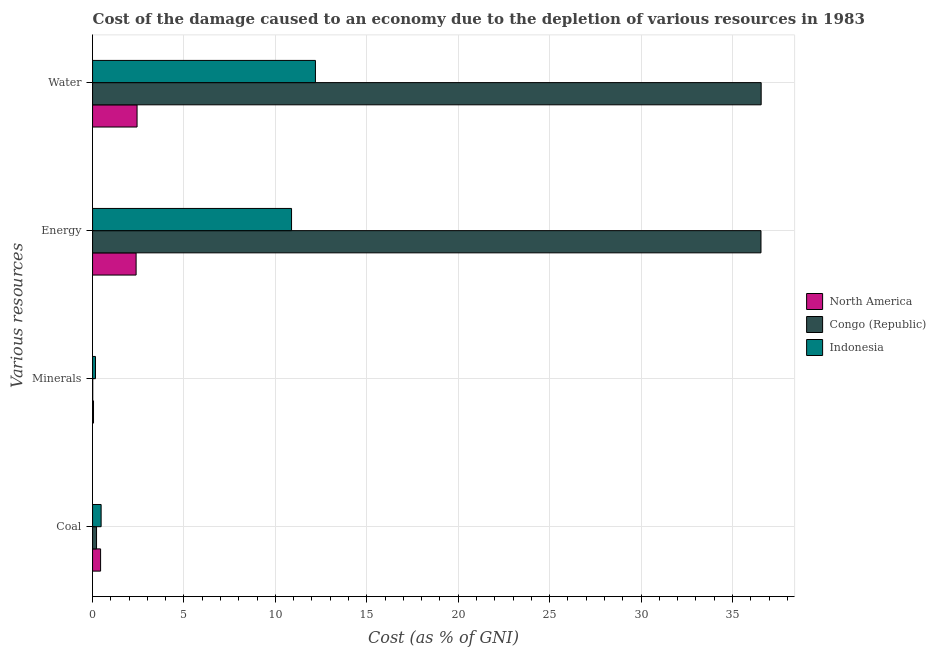Are the number of bars on each tick of the Y-axis equal?
Your response must be concise. Yes. How many bars are there on the 2nd tick from the top?
Give a very brief answer. 3. How many bars are there on the 1st tick from the bottom?
Provide a short and direct response. 3. What is the label of the 3rd group of bars from the top?
Provide a succinct answer. Minerals. What is the cost of damage due to depletion of water in Congo (Republic)?
Offer a terse response. 36.57. Across all countries, what is the maximum cost of damage due to depletion of energy?
Your response must be concise. 36.56. Across all countries, what is the minimum cost of damage due to depletion of energy?
Your answer should be compact. 2.38. In which country was the cost of damage due to depletion of energy maximum?
Offer a terse response. Congo (Republic). In which country was the cost of damage due to depletion of minerals minimum?
Keep it short and to the point. Congo (Republic). What is the total cost of damage due to depletion of minerals in the graph?
Offer a terse response. 0.22. What is the difference between the cost of damage due to depletion of minerals in North America and that in Indonesia?
Your answer should be compact. -0.11. What is the difference between the cost of damage due to depletion of water in Indonesia and the cost of damage due to depletion of minerals in North America?
Your response must be concise. 12.14. What is the average cost of damage due to depletion of coal per country?
Give a very brief answer. 0.37. What is the difference between the cost of damage due to depletion of minerals and cost of damage due to depletion of energy in Indonesia?
Provide a short and direct response. -10.72. What is the ratio of the cost of damage due to depletion of water in North America to that in Indonesia?
Provide a short and direct response. 0.2. Is the cost of damage due to depletion of energy in North America less than that in Congo (Republic)?
Your response must be concise. Yes. Is the difference between the cost of damage due to depletion of coal in North America and Indonesia greater than the difference between the cost of damage due to depletion of energy in North America and Indonesia?
Your answer should be compact. Yes. What is the difference between the highest and the second highest cost of damage due to depletion of water?
Provide a succinct answer. 24.38. What is the difference between the highest and the lowest cost of damage due to depletion of energy?
Offer a terse response. 34.17. Is the sum of the cost of damage due to depletion of minerals in Indonesia and Congo (Republic) greater than the maximum cost of damage due to depletion of coal across all countries?
Make the answer very short. No. What does the 2nd bar from the bottom in Water represents?
Keep it short and to the point. Congo (Republic). How many countries are there in the graph?
Make the answer very short. 3. Does the graph contain grids?
Ensure brevity in your answer.  Yes. Where does the legend appear in the graph?
Give a very brief answer. Center right. How are the legend labels stacked?
Give a very brief answer. Vertical. What is the title of the graph?
Your response must be concise. Cost of the damage caused to an economy due to the depletion of various resources in 1983 . Does "Fragile and conflict affected situations" appear as one of the legend labels in the graph?
Provide a succinct answer. No. What is the label or title of the X-axis?
Provide a short and direct response. Cost (as % of GNI). What is the label or title of the Y-axis?
Ensure brevity in your answer.  Various resources. What is the Cost (as % of GNI) in North America in Coal?
Keep it short and to the point. 0.44. What is the Cost (as % of GNI) of Congo (Republic) in Coal?
Make the answer very short. 0.22. What is the Cost (as % of GNI) of Indonesia in Coal?
Make the answer very short. 0.47. What is the Cost (as % of GNI) in North America in Minerals?
Ensure brevity in your answer.  0.05. What is the Cost (as % of GNI) in Congo (Republic) in Minerals?
Your response must be concise. 0.01. What is the Cost (as % of GNI) of Indonesia in Minerals?
Give a very brief answer. 0.16. What is the Cost (as % of GNI) of North America in Energy?
Keep it short and to the point. 2.38. What is the Cost (as % of GNI) in Congo (Republic) in Energy?
Your response must be concise. 36.56. What is the Cost (as % of GNI) of Indonesia in Energy?
Your response must be concise. 10.88. What is the Cost (as % of GNI) of North America in Water?
Provide a succinct answer. 2.43. What is the Cost (as % of GNI) of Congo (Republic) in Water?
Keep it short and to the point. 36.57. What is the Cost (as % of GNI) of Indonesia in Water?
Offer a very short reply. 12.19. Across all Various resources, what is the maximum Cost (as % of GNI) of North America?
Offer a very short reply. 2.43. Across all Various resources, what is the maximum Cost (as % of GNI) in Congo (Republic)?
Keep it short and to the point. 36.57. Across all Various resources, what is the maximum Cost (as % of GNI) of Indonesia?
Offer a very short reply. 12.19. Across all Various resources, what is the minimum Cost (as % of GNI) of North America?
Your answer should be very brief. 0.05. Across all Various resources, what is the minimum Cost (as % of GNI) of Congo (Republic)?
Ensure brevity in your answer.  0.01. Across all Various resources, what is the minimum Cost (as % of GNI) of Indonesia?
Keep it short and to the point. 0.16. What is the total Cost (as % of GNI) of North America in the graph?
Give a very brief answer. 5.31. What is the total Cost (as % of GNI) of Congo (Republic) in the graph?
Your answer should be very brief. 73.35. What is the total Cost (as % of GNI) in Indonesia in the graph?
Ensure brevity in your answer.  23.7. What is the difference between the Cost (as % of GNI) of North America in Coal and that in Minerals?
Your response must be concise. 0.39. What is the difference between the Cost (as % of GNI) of Congo (Republic) in Coal and that in Minerals?
Your answer should be very brief. 0.21. What is the difference between the Cost (as % of GNI) in Indonesia in Coal and that in Minerals?
Provide a succinct answer. 0.31. What is the difference between the Cost (as % of GNI) of North America in Coal and that in Energy?
Give a very brief answer. -1.94. What is the difference between the Cost (as % of GNI) of Congo (Republic) in Coal and that in Energy?
Give a very brief answer. -36.34. What is the difference between the Cost (as % of GNI) in Indonesia in Coal and that in Energy?
Make the answer very short. -10.41. What is the difference between the Cost (as % of GNI) in North America in Coal and that in Water?
Offer a very short reply. -1.99. What is the difference between the Cost (as % of GNI) in Congo (Republic) in Coal and that in Water?
Your answer should be very brief. -36.35. What is the difference between the Cost (as % of GNI) of Indonesia in Coal and that in Water?
Provide a succinct answer. -11.72. What is the difference between the Cost (as % of GNI) in North America in Minerals and that in Energy?
Provide a succinct answer. -2.33. What is the difference between the Cost (as % of GNI) in Congo (Republic) in Minerals and that in Energy?
Offer a very short reply. -36.55. What is the difference between the Cost (as % of GNI) in Indonesia in Minerals and that in Energy?
Provide a succinct answer. -10.72. What is the difference between the Cost (as % of GNI) in North America in Minerals and that in Water?
Offer a very short reply. -2.38. What is the difference between the Cost (as % of GNI) in Congo (Republic) in Minerals and that in Water?
Your response must be concise. -36.56. What is the difference between the Cost (as % of GNI) of Indonesia in Minerals and that in Water?
Offer a very short reply. -12.03. What is the difference between the Cost (as % of GNI) of North America in Energy and that in Water?
Ensure brevity in your answer.  -0.05. What is the difference between the Cost (as % of GNI) in Congo (Republic) in Energy and that in Water?
Offer a very short reply. -0.01. What is the difference between the Cost (as % of GNI) in Indonesia in Energy and that in Water?
Give a very brief answer. -1.31. What is the difference between the Cost (as % of GNI) of North America in Coal and the Cost (as % of GNI) of Congo (Republic) in Minerals?
Ensure brevity in your answer.  0.43. What is the difference between the Cost (as % of GNI) in North America in Coal and the Cost (as % of GNI) in Indonesia in Minerals?
Ensure brevity in your answer.  0.28. What is the difference between the Cost (as % of GNI) of Congo (Republic) in Coal and the Cost (as % of GNI) of Indonesia in Minerals?
Provide a succinct answer. 0.06. What is the difference between the Cost (as % of GNI) in North America in Coal and the Cost (as % of GNI) in Congo (Republic) in Energy?
Offer a terse response. -36.12. What is the difference between the Cost (as % of GNI) in North America in Coal and the Cost (as % of GNI) in Indonesia in Energy?
Keep it short and to the point. -10.44. What is the difference between the Cost (as % of GNI) in Congo (Republic) in Coal and the Cost (as % of GNI) in Indonesia in Energy?
Keep it short and to the point. -10.66. What is the difference between the Cost (as % of GNI) in North America in Coal and the Cost (as % of GNI) in Congo (Republic) in Water?
Offer a terse response. -36.13. What is the difference between the Cost (as % of GNI) in North America in Coal and the Cost (as % of GNI) in Indonesia in Water?
Offer a very short reply. -11.75. What is the difference between the Cost (as % of GNI) in Congo (Republic) in Coal and the Cost (as % of GNI) in Indonesia in Water?
Ensure brevity in your answer.  -11.97. What is the difference between the Cost (as % of GNI) in North America in Minerals and the Cost (as % of GNI) in Congo (Republic) in Energy?
Give a very brief answer. -36.5. What is the difference between the Cost (as % of GNI) of North America in Minerals and the Cost (as % of GNI) of Indonesia in Energy?
Offer a terse response. -10.83. What is the difference between the Cost (as % of GNI) of Congo (Republic) in Minerals and the Cost (as % of GNI) of Indonesia in Energy?
Keep it short and to the point. -10.87. What is the difference between the Cost (as % of GNI) of North America in Minerals and the Cost (as % of GNI) of Congo (Republic) in Water?
Your answer should be very brief. -36.51. What is the difference between the Cost (as % of GNI) of North America in Minerals and the Cost (as % of GNI) of Indonesia in Water?
Your response must be concise. -12.14. What is the difference between the Cost (as % of GNI) in Congo (Republic) in Minerals and the Cost (as % of GNI) in Indonesia in Water?
Ensure brevity in your answer.  -12.18. What is the difference between the Cost (as % of GNI) in North America in Energy and the Cost (as % of GNI) in Congo (Republic) in Water?
Your answer should be compact. -34.18. What is the difference between the Cost (as % of GNI) in North America in Energy and the Cost (as % of GNI) in Indonesia in Water?
Make the answer very short. -9.81. What is the difference between the Cost (as % of GNI) of Congo (Republic) in Energy and the Cost (as % of GNI) of Indonesia in Water?
Provide a short and direct response. 24.37. What is the average Cost (as % of GNI) in North America per Various resources?
Offer a terse response. 1.33. What is the average Cost (as % of GNI) in Congo (Republic) per Various resources?
Make the answer very short. 18.34. What is the average Cost (as % of GNI) of Indonesia per Various resources?
Ensure brevity in your answer.  5.92. What is the difference between the Cost (as % of GNI) of North America and Cost (as % of GNI) of Congo (Republic) in Coal?
Your response must be concise. 0.22. What is the difference between the Cost (as % of GNI) in North America and Cost (as % of GNI) in Indonesia in Coal?
Give a very brief answer. -0.03. What is the difference between the Cost (as % of GNI) in Congo (Republic) and Cost (as % of GNI) in Indonesia in Coal?
Keep it short and to the point. -0.25. What is the difference between the Cost (as % of GNI) of North America and Cost (as % of GNI) of Congo (Republic) in Minerals?
Keep it short and to the point. 0.04. What is the difference between the Cost (as % of GNI) of North America and Cost (as % of GNI) of Indonesia in Minerals?
Keep it short and to the point. -0.11. What is the difference between the Cost (as % of GNI) of Congo (Republic) and Cost (as % of GNI) of Indonesia in Minerals?
Keep it short and to the point. -0.15. What is the difference between the Cost (as % of GNI) of North America and Cost (as % of GNI) of Congo (Republic) in Energy?
Make the answer very short. -34.17. What is the difference between the Cost (as % of GNI) of North America and Cost (as % of GNI) of Indonesia in Energy?
Your answer should be very brief. -8.5. What is the difference between the Cost (as % of GNI) in Congo (Republic) and Cost (as % of GNI) in Indonesia in Energy?
Your answer should be compact. 25.67. What is the difference between the Cost (as % of GNI) in North America and Cost (as % of GNI) in Congo (Republic) in Water?
Keep it short and to the point. -34.13. What is the difference between the Cost (as % of GNI) of North America and Cost (as % of GNI) of Indonesia in Water?
Provide a succinct answer. -9.75. What is the difference between the Cost (as % of GNI) in Congo (Republic) and Cost (as % of GNI) in Indonesia in Water?
Your answer should be compact. 24.38. What is the ratio of the Cost (as % of GNI) in North America in Coal to that in Minerals?
Offer a terse response. 8.45. What is the ratio of the Cost (as % of GNI) in Congo (Republic) in Coal to that in Minerals?
Keep it short and to the point. 21.12. What is the ratio of the Cost (as % of GNI) in Indonesia in Coal to that in Minerals?
Offer a very short reply. 2.93. What is the ratio of the Cost (as % of GNI) of North America in Coal to that in Energy?
Your answer should be compact. 0.18. What is the ratio of the Cost (as % of GNI) of Congo (Republic) in Coal to that in Energy?
Your answer should be compact. 0.01. What is the ratio of the Cost (as % of GNI) of Indonesia in Coal to that in Energy?
Keep it short and to the point. 0.04. What is the ratio of the Cost (as % of GNI) of North America in Coal to that in Water?
Your answer should be compact. 0.18. What is the ratio of the Cost (as % of GNI) of Congo (Republic) in Coal to that in Water?
Give a very brief answer. 0.01. What is the ratio of the Cost (as % of GNI) of Indonesia in Coal to that in Water?
Offer a very short reply. 0.04. What is the ratio of the Cost (as % of GNI) of North America in Minerals to that in Energy?
Ensure brevity in your answer.  0.02. What is the ratio of the Cost (as % of GNI) in Congo (Republic) in Minerals to that in Energy?
Your answer should be very brief. 0. What is the ratio of the Cost (as % of GNI) of Indonesia in Minerals to that in Energy?
Offer a terse response. 0.01. What is the ratio of the Cost (as % of GNI) in North America in Minerals to that in Water?
Provide a short and direct response. 0.02. What is the ratio of the Cost (as % of GNI) of Congo (Republic) in Minerals to that in Water?
Give a very brief answer. 0. What is the ratio of the Cost (as % of GNI) in Indonesia in Minerals to that in Water?
Provide a succinct answer. 0.01. What is the ratio of the Cost (as % of GNI) in North America in Energy to that in Water?
Make the answer very short. 0.98. What is the ratio of the Cost (as % of GNI) of Congo (Republic) in Energy to that in Water?
Keep it short and to the point. 1. What is the ratio of the Cost (as % of GNI) in Indonesia in Energy to that in Water?
Make the answer very short. 0.89. What is the difference between the highest and the second highest Cost (as % of GNI) of North America?
Make the answer very short. 0.05. What is the difference between the highest and the second highest Cost (as % of GNI) in Congo (Republic)?
Offer a terse response. 0.01. What is the difference between the highest and the second highest Cost (as % of GNI) of Indonesia?
Your answer should be very brief. 1.31. What is the difference between the highest and the lowest Cost (as % of GNI) in North America?
Your answer should be very brief. 2.38. What is the difference between the highest and the lowest Cost (as % of GNI) in Congo (Republic)?
Make the answer very short. 36.56. What is the difference between the highest and the lowest Cost (as % of GNI) of Indonesia?
Your answer should be very brief. 12.03. 